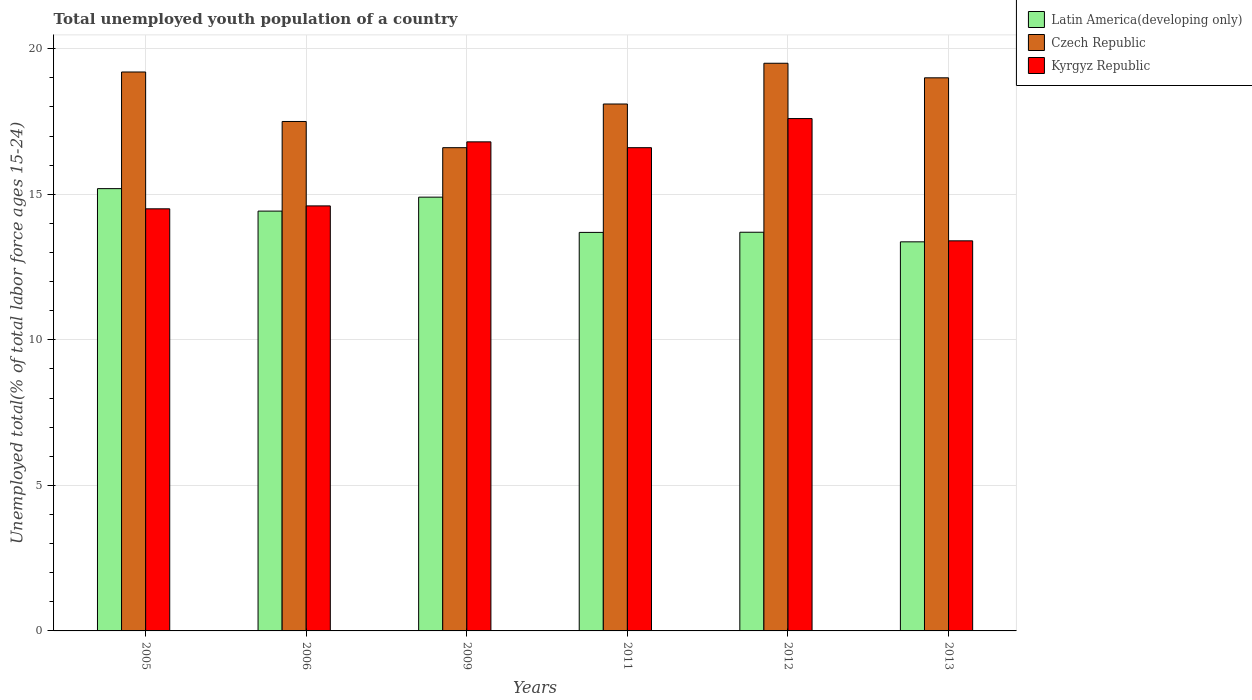How many different coloured bars are there?
Provide a succinct answer. 3. How many bars are there on the 6th tick from the left?
Provide a short and direct response. 3. How many bars are there on the 2nd tick from the right?
Your response must be concise. 3. What is the label of the 3rd group of bars from the left?
Keep it short and to the point. 2009. In how many cases, is the number of bars for a given year not equal to the number of legend labels?
Make the answer very short. 0. What is the percentage of total unemployed youth population of a country in Latin America(developing only) in 2009?
Provide a short and direct response. 14.9. Across all years, what is the maximum percentage of total unemployed youth population of a country in Kyrgyz Republic?
Give a very brief answer. 17.6. Across all years, what is the minimum percentage of total unemployed youth population of a country in Czech Republic?
Give a very brief answer. 16.6. In which year was the percentage of total unemployed youth population of a country in Kyrgyz Republic maximum?
Make the answer very short. 2012. In which year was the percentage of total unemployed youth population of a country in Latin America(developing only) minimum?
Offer a terse response. 2013. What is the total percentage of total unemployed youth population of a country in Kyrgyz Republic in the graph?
Your response must be concise. 93.5. What is the difference between the percentage of total unemployed youth population of a country in Latin America(developing only) in 2006 and that in 2013?
Give a very brief answer. 1.06. What is the difference between the percentage of total unemployed youth population of a country in Kyrgyz Republic in 2009 and the percentage of total unemployed youth population of a country in Czech Republic in 2012?
Keep it short and to the point. -2.7. What is the average percentage of total unemployed youth population of a country in Czech Republic per year?
Keep it short and to the point. 18.32. In the year 2012, what is the difference between the percentage of total unemployed youth population of a country in Latin America(developing only) and percentage of total unemployed youth population of a country in Czech Republic?
Give a very brief answer. -5.8. What is the ratio of the percentage of total unemployed youth population of a country in Latin America(developing only) in 2005 to that in 2006?
Offer a terse response. 1.05. Is the difference between the percentage of total unemployed youth population of a country in Latin America(developing only) in 2005 and 2009 greater than the difference between the percentage of total unemployed youth population of a country in Czech Republic in 2005 and 2009?
Your response must be concise. No. What is the difference between the highest and the second highest percentage of total unemployed youth population of a country in Czech Republic?
Keep it short and to the point. 0.3. What is the difference between the highest and the lowest percentage of total unemployed youth population of a country in Kyrgyz Republic?
Offer a very short reply. 4.2. What does the 3rd bar from the left in 2006 represents?
Give a very brief answer. Kyrgyz Republic. What does the 1st bar from the right in 2006 represents?
Offer a terse response. Kyrgyz Republic. How many bars are there?
Give a very brief answer. 18. Are all the bars in the graph horizontal?
Your answer should be very brief. No. Are the values on the major ticks of Y-axis written in scientific E-notation?
Provide a succinct answer. No. What is the title of the graph?
Your answer should be very brief. Total unemployed youth population of a country. What is the label or title of the X-axis?
Provide a succinct answer. Years. What is the label or title of the Y-axis?
Make the answer very short. Unemployed total(% of total labor force ages 15-24). What is the Unemployed total(% of total labor force ages 15-24) in Latin America(developing only) in 2005?
Your answer should be compact. 15.19. What is the Unemployed total(% of total labor force ages 15-24) in Czech Republic in 2005?
Offer a very short reply. 19.2. What is the Unemployed total(% of total labor force ages 15-24) of Kyrgyz Republic in 2005?
Make the answer very short. 14.5. What is the Unemployed total(% of total labor force ages 15-24) in Latin America(developing only) in 2006?
Your answer should be compact. 14.42. What is the Unemployed total(% of total labor force ages 15-24) in Kyrgyz Republic in 2006?
Offer a terse response. 14.6. What is the Unemployed total(% of total labor force ages 15-24) of Latin America(developing only) in 2009?
Offer a terse response. 14.9. What is the Unemployed total(% of total labor force ages 15-24) in Czech Republic in 2009?
Give a very brief answer. 16.6. What is the Unemployed total(% of total labor force ages 15-24) in Kyrgyz Republic in 2009?
Keep it short and to the point. 16.8. What is the Unemployed total(% of total labor force ages 15-24) in Latin America(developing only) in 2011?
Give a very brief answer. 13.69. What is the Unemployed total(% of total labor force ages 15-24) of Czech Republic in 2011?
Your answer should be compact. 18.1. What is the Unemployed total(% of total labor force ages 15-24) in Kyrgyz Republic in 2011?
Your response must be concise. 16.6. What is the Unemployed total(% of total labor force ages 15-24) of Latin America(developing only) in 2012?
Make the answer very short. 13.7. What is the Unemployed total(% of total labor force ages 15-24) in Czech Republic in 2012?
Your answer should be very brief. 19.5. What is the Unemployed total(% of total labor force ages 15-24) of Kyrgyz Republic in 2012?
Your response must be concise. 17.6. What is the Unemployed total(% of total labor force ages 15-24) in Latin America(developing only) in 2013?
Make the answer very short. 13.37. What is the Unemployed total(% of total labor force ages 15-24) in Czech Republic in 2013?
Give a very brief answer. 19. What is the Unemployed total(% of total labor force ages 15-24) in Kyrgyz Republic in 2013?
Keep it short and to the point. 13.4. Across all years, what is the maximum Unemployed total(% of total labor force ages 15-24) of Latin America(developing only)?
Make the answer very short. 15.19. Across all years, what is the maximum Unemployed total(% of total labor force ages 15-24) in Czech Republic?
Ensure brevity in your answer.  19.5. Across all years, what is the maximum Unemployed total(% of total labor force ages 15-24) in Kyrgyz Republic?
Keep it short and to the point. 17.6. Across all years, what is the minimum Unemployed total(% of total labor force ages 15-24) of Latin America(developing only)?
Your response must be concise. 13.37. Across all years, what is the minimum Unemployed total(% of total labor force ages 15-24) of Czech Republic?
Your answer should be compact. 16.6. Across all years, what is the minimum Unemployed total(% of total labor force ages 15-24) of Kyrgyz Republic?
Provide a short and direct response. 13.4. What is the total Unemployed total(% of total labor force ages 15-24) in Latin America(developing only) in the graph?
Make the answer very short. 85.27. What is the total Unemployed total(% of total labor force ages 15-24) in Czech Republic in the graph?
Your answer should be compact. 109.9. What is the total Unemployed total(% of total labor force ages 15-24) of Kyrgyz Republic in the graph?
Provide a short and direct response. 93.5. What is the difference between the Unemployed total(% of total labor force ages 15-24) of Latin America(developing only) in 2005 and that in 2006?
Your answer should be very brief. 0.77. What is the difference between the Unemployed total(% of total labor force ages 15-24) of Czech Republic in 2005 and that in 2006?
Give a very brief answer. 1.7. What is the difference between the Unemployed total(% of total labor force ages 15-24) of Latin America(developing only) in 2005 and that in 2009?
Provide a short and direct response. 0.29. What is the difference between the Unemployed total(% of total labor force ages 15-24) of Latin America(developing only) in 2005 and that in 2011?
Ensure brevity in your answer.  1.5. What is the difference between the Unemployed total(% of total labor force ages 15-24) of Latin America(developing only) in 2005 and that in 2012?
Make the answer very short. 1.5. What is the difference between the Unemployed total(% of total labor force ages 15-24) of Czech Republic in 2005 and that in 2012?
Ensure brevity in your answer.  -0.3. What is the difference between the Unemployed total(% of total labor force ages 15-24) of Kyrgyz Republic in 2005 and that in 2012?
Give a very brief answer. -3.1. What is the difference between the Unemployed total(% of total labor force ages 15-24) in Latin America(developing only) in 2005 and that in 2013?
Give a very brief answer. 1.83. What is the difference between the Unemployed total(% of total labor force ages 15-24) in Czech Republic in 2005 and that in 2013?
Your response must be concise. 0.2. What is the difference between the Unemployed total(% of total labor force ages 15-24) in Latin America(developing only) in 2006 and that in 2009?
Ensure brevity in your answer.  -0.48. What is the difference between the Unemployed total(% of total labor force ages 15-24) in Czech Republic in 2006 and that in 2009?
Make the answer very short. 0.9. What is the difference between the Unemployed total(% of total labor force ages 15-24) of Kyrgyz Republic in 2006 and that in 2009?
Offer a very short reply. -2.2. What is the difference between the Unemployed total(% of total labor force ages 15-24) of Latin America(developing only) in 2006 and that in 2011?
Your answer should be very brief. 0.73. What is the difference between the Unemployed total(% of total labor force ages 15-24) in Kyrgyz Republic in 2006 and that in 2011?
Your answer should be very brief. -2. What is the difference between the Unemployed total(% of total labor force ages 15-24) of Latin America(developing only) in 2006 and that in 2012?
Give a very brief answer. 0.73. What is the difference between the Unemployed total(% of total labor force ages 15-24) in Czech Republic in 2006 and that in 2012?
Provide a short and direct response. -2. What is the difference between the Unemployed total(% of total labor force ages 15-24) of Latin America(developing only) in 2006 and that in 2013?
Your response must be concise. 1.06. What is the difference between the Unemployed total(% of total labor force ages 15-24) in Kyrgyz Republic in 2006 and that in 2013?
Provide a succinct answer. 1.2. What is the difference between the Unemployed total(% of total labor force ages 15-24) in Latin America(developing only) in 2009 and that in 2011?
Provide a short and direct response. 1.21. What is the difference between the Unemployed total(% of total labor force ages 15-24) in Latin America(developing only) in 2009 and that in 2012?
Offer a very short reply. 1.21. What is the difference between the Unemployed total(% of total labor force ages 15-24) of Czech Republic in 2009 and that in 2012?
Offer a very short reply. -2.9. What is the difference between the Unemployed total(% of total labor force ages 15-24) of Latin America(developing only) in 2009 and that in 2013?
Offer a terse response. 1.53. What is the difference between the Unemployed total(% of total labor force ages 15-24) of Latin America(developing only) in 2011 and that in 2012?
Your answer should be compact. -0.01. What is the difference between the Unemployed total(% of total labor force ages 15-24) in Czech Republic in 2011 and that in 2012?
Ensure brevity in your answer.  -1.4. What is the difference between the Unemployed total(% of total labor force ages 15-24) of Kyrgyz Republic in 2011 and that in 2012?
Provide a succinct answer. -1. What is the difference between the Unemployed total(% of total labor force ages 15-24) in Latin America(developing only) in 2011 and that in 2013?
Offer a very short reply. 0.32. What is the difference between the Unemployed total(% of total labor force ages 15-24) in Czech Republic in 2011 and that in 2013?
Your response must be concise. -0.9. What is the difference between the Unemployed total(% of total labor force ages 15-24) in Latin America(developing only) in 2012 and that in 2013?
Your answer should be very brief. 0.33. What is the difference between the Unemployed total(% of total labor force ages 15-24) in Latin America(developing only) in 2005 and the Unemployed total(% of total labor force ages 15-24) in Czech Republic in 2006?
Give a very brief answer. -2.31. What is the difference between the Unemployed total(% of total labor force ages 15-24) in Latin America(developing only) in 2005 and the Unemployed total(% of total labor force ages 15-24) in Kyrgyz Republic in 2006?
Provide a succinct answer. 0.59. What is the difference between the Unemployed total(% of total labor force ages 15-24) of Latin America(developing only) in 2005 and the Unemployed total(% of total labor force ages 15-24) of Czech Republic in 2009?
Provide a succinct answer. -1.41. What is the difference between the Unemployed total(% of total labor force ages 15-24) of Latin America(developing only) in 2005 and the Unemployed total(% of total labor force ages 15-24) of Kyrgyz Republic in 2009?
Keep it short and to the point. -1.61. What is the difference between the Unemployed total(% of total labor force ages 15-24) of Latin America(developing only) in 2005 and the Unemployed total(% of total labor force ages 15-24) of Czech Republic in 2011?
Offer a very short reply. -2.91. What is the difference between the Unemployed total(% of total labor force ages 15-24) in Latin America(developing only) in 2005 and the Unemployed total(% of total labor force ages 15-24) in Kyrgyz Republic in 2011?
Give a very brief answer. -1.41. What is the difference between the Unemployed total(% of total labor force ages 15-24) in Latin America(developing only) in 2005 and the Unemployed total(% of total labor force ages 15-24) in Czech Republic in 2012?
Ensure brevity in your answer.  -4.31. What is the difference between the Unemployed total(% of total labor force ages 15-24) of Latin America(developing only) in 2005 and the Unemployed total(% of total labor force ages 15-24) of Kyrgyz Republic in 2012?
Offer a very short reply. -2.41. What is the difference between the Unemployed total(% of total labor force ages 15-24) of Latin America(developing only) in 2005 and the Unemployed total(% of total labor force ages 15-24) of Czech Republic in 2013?
Ensure brevity in your answer.  -3.81. What is the difference between the Unemployed total(% of total labor force ages 15-24) of Latin America(developing only) in 2005 and the Unemployed total(% of total labor force ages 15-24) of Kyrgyz Republic in 2013?
Provide a short and direct response. 1.79. What is the difference between the Unemployed total(% of total labor force ages 15-24) in Latin America(developing only) in 2006 and the Unemployed total(% of total labor force ages 15-24) in Czech Republic in 2009?
Offer a very short reply. -2.18. What is the difference between the Unemployed total(% of total labor force ages 15-24) of Latin America(developing only) in 2006 and the Unemployed total(% of total labor force ages 15-24) of Kyrgyz Republic in 2009?
Provide a short and direct response. -2.38. What is the difference between the Unemployed total(% of total labor force ages 15-24) of Czech Republic in 2006 and the Unemployed total(% of total labor force ages 15-24) of Kyrgyz Republic in 2009?
Offer a very short reply. 0.7. What is the difference between the Unemployed total(% of total labor force ages 15-24) in Latin America(developing only) in 2006 and the Unemployed total(% of total labor force ages 15-24) in Czech Republic in 2011?
Your response must be concise. -3.68. What is the difference between the Unemployed total(% of total labor force ages 15-24) of Latin America(developing only) in 2006 and the Unemployed total(% of total labor force ages 15-24) of Kyrgyz Republic in 2011?
Give a very brief answer. -2.18. What is the difference between the Unemployed total(% of total labor force ages 15-24) in Latin America(developing only) in 2006 and the Unemployed total(% of total labor force ages 15-24) in Czech Republic in 2012?
Make the answer very short. -5.08. What is the difference between the Unemployed total(% of total labor force ages 15-24) in Latin America(developing only) in 2006 and the Unemployed total(% of total labor force ages 15-24) in Kyrgyz Republic in 2012?
Your response must be concise. -3.18. What is the difference between the Unemployed total(% of total labor force ages 15-24) in Latin America(developing only) in 2006 and the Unemployed total(% of total labor force ages 15-24) in Czech Republic in 2013?
Provide a succinct answer. -4.58. What is the difference between the Unemployed total(% of total labor force ages 15-24) of Latin America(developing only) in 2006 and the Unemployed total(% of total labor force ages 15-24) of Kyrgyz Republic in 2013?
Offer a very short reply. 1.02. What is the difference between the Unemployed total(% of total labor force ages 15-24) in Latin America(developing only) in 2009 and the Unemployed total(% of total labor force ages 15-24) in Czech Republic in 2011?
Your answer should be compact. -3.2. What is the difference between the Unemployed total(% of total labor force ages 15-24) of Latin America(developing only) in 2009 and the Unemployed total(% of total labor force ages 15-24) of Kyrgyz Republic in 2011?
Offer a terse response. -1.7. What is the difference between the Unemployed total(% of total labor force ages 15-24) in Czech Republic in 2009 and the Unemployed total(% of total labor force ages 15-24) in Kyrgyz Republic in 2011?
Offer a very short reply. 0. What is the difference between the Unemployed total(% of total labor force ages 15-24) in Latin America(developing only) in 2009 and the Unemployed total(% of total labor force ages 15-24) in Czech Republic in 2012?
Give a very brief answer. -4.6. What is the difference between the Unemployed total(% of total labor force ages 15-24) of Latin America(developing only) in 2009 and the Unemployed total(% of total labor force ages 15-24) of Kyrgyz Republic in 2012?
Your answer should be compact. -2.7. What is the difference between the Unemployed total(% of total labor force ages 15-24) of Czech Republic in 2009 and the Unemployed total(% of total labor force ages 15-24) of Kyrgyz Republic in 2012?
Make the answer very short. -1. What is the difference between the Unemployed total(% of total labor force ages 15-24) of Latin America(developing only) in 2009 and the Unemployed total(% of total labor force ages 15-24) of Czech Republic in 2013?
Your response must be concise. -4.1. What is the difference between the Unemployed total(% of total labor force ages 15-24) of Latin America(developing only) in 2009 and the Unemployed total(% of total labor force ages 15-24) of Kyrgyz Republic in 2013?
Your answer should be very brief. 1.5. What is the difference between the Unemployed total(% of total labor force ages 15-24) in Latin America(developing only) in 2011 and the Unemployed total(% of total labor force ages 15-24) in Czech Republic in 2012?
Your response must be concise. -5.81. What is the difference between the Unemployed total(% of total labor force ages 15-24) in Latin America(developing only) in 2011 and the Unemployed total(% of total labor force ages 15-24) in Kyrgyz Republic in 2012?
Provide a short and direct response. -3.91. What is the difference between the Unemployed total(% of total labor force ages 15-24) of Czech Republic in 2011 and the Unemployed total(% of total labor force ages 15-24) of Kyrgyz Republic in 2012?
Your response must be concise. 0.5. What is the difference between the Unemployed total(% of total labor force ages 15-24) of Latin America(developing only) in 2011 and the Unemployed total(% of total labor force ages 15-24) of Czech Republic in 2013?
Ensure brevity in your answer.  -5.31. What is the difference between the Unemployed total(% of total labor force ages 15-24) of Latin America(developing only) in 2011 and the Unemployed total(% of total labor force ages 15-24) of Kyrgyz Republic in 2013?
Ensure brevity in your answer.  0.29. What is the difference between the Unemployed total(% of total labor force ages 15-24) in Czech Republic in 2011 and the Unemployed total(% of total labor force ages 15-24) in Kyrgyz Republic in 2013?
Keep it short and to the point. 4.7. What is the difference between the Unemployed total(% of total labor force ages 15-24) in Latin America(developing only) in 2012 and the Unemployed total(% of total labor force ages 15-24) in Czech Republic in 2013?
Provide a short and direct response. -5.3. What is the difference between the Unemployed total(% of total labor force ages 15-24) in Latin America(developing only) in 2012 and the Unemployed total(% of total labor force ages 15-24) in Kyrgyz Republic in 2013?
Make the answer very short. 0.3. What is the difference between the Unemployed total(% of total labor force ages 15-24) in Czech Republic in 2012 and the Unemployed total(% of total labor force ages 15-24) in Kyrgyz Republic in 2013?
Ensure brevity in your answer.  6.1. What is the average Unemployed total(% of total labor force ages 15-24) in Latin America(developing only) per year?
Ensure brevity in your answer.  14.21. What is the average Unemployed total(% of total labor force ages 15-24) of Czech Republic per year?
Ensure brevity in your answer.  18.32. What is the average Unemployed total(% of total labor force ages 15-24) of Kyrgyz Republic per year?
Keep it short and to the point. 15.58. In the year 2005, what is the difference between the Unemployed total(% of total labor force ages 15-24) of Latin America(developing only) and Unemployed total(% of total labor force ages 15-24) of Czech Republic?
Offer a very short reply. -4.01. In the year 2005, what is the difference between the Unemployed total(% of total labor force ages 15-24) in Latin America(developing only) and Unemployed total(% of total labor force ages 15-24) in Kyrgyz Republic?
Your answer should be compact. 0.69. In the year 2005, what is the difference between the Unemployed total(% of total labor force ages 15-24) in Czech Republic and Unemployed total(% of total labor force ages 15-24) in Kyrgyz Republic?
Make the answer very short. 4.7. In the year 2006, what is the difference between the Unemployed total(% of total labor force ages 15-24) in Latin America(developing only) and Unemployed total(% of total labor force ages 15-24) in Czech Republic?
Offer a very short reply. -3.08. In the year 2006, what is the difference between the Unemployed total(% of total labor force ages 15-24) of Latin America(developing only) and Unemployed total(% of total labor force ages 15-24) of Kyrgyz Republic?
Give a very brief answer. -0.18. In the year 2009, what is the difference between the Unemployed total(% of total labor force ages 15-24) in Latin America(developing only) and Unemployed total(% of total labor force ages 15-24) in Czech Republic?
Make the answer very short. -1.7. In the year 2009, what is the difference between the Unemployed total(% of total labor force ages 15-24) of Latin America(developing only) and Unemployed total(% of total labor force ages 15-24) of Kyrgyz Republic?
Provide a short and direct response. -1.9. In the year 2011, what is the difference between the Unemployed total(% of total labor force ages 15-24) in Latin America(developing only) and Unemployed total(% of total labor force ages 15-24) in Czech Republic?
Your answer should be very brief. -4.41. In the year 2011, what is the difference between the Unemployed total(% of total labor force ages 15-24) of Latin America(developing only) and Unemployed total(% of total labor force ages 15-24) of Kyrgyz Republic?
Your response must be concise. -2.91. In the year 2012, what is the difference between the Unemployed total(% of total labor force ages 15-24) of Latin America(developing only) and Unemployed total(% of total labor force ages 15-24) of Czech Republic?
Your response must be concise. -5.8. In the year 2012, what is the difference between the Unemployed total(% of total labor force ages 15-24) of Latin America(developing only) and Unemployed total(% of total labor force ages 15-24) of Kyrgyz Republic?
Provide a succinct answer. -3.9. In the year 2012, what is the difference between the Unemployed total(% of total labor force ages 15-24) of Czech Republic and Unemployed total(% of total labor force ages 15-24) of Kyrgyz Republic?
Your answer should be very brief. 1.9. In the year 2013, what is the difference between the Unemployed total(% of total labor force ages 15-24) of Latin America(developing only) and Unemployed total(% of total labor force ages 15-24) of Czech Republic?
Provide a succinct answer. -5.63. In the year 2013, what is the difference between the Unemployed total(% of total labor force ages 15-24) in Latin America(developing only) and Unemployed total(% of total labor force ages 15-24) in Kyrgyz Republic?
Offer a very short reply. -0.03. In the year 2013, what is the difference between the Unemployed total(% of total labor force ages 15-24) in Czech Republic and Unemployed total(% of total labor force ages 15-24) in Kyrgyz Republic?
Give a very brief answer. 5.6. What is the ratio of the Unemployed total(% of total labor force ages 15-24) of Latin America(developing only) in 2005 to that in 2006?
Offer a terse response. 1.05. What is the ratio of the Unemployed total(% of total labor force ages 15-24) of Czech Republic in 2005 to that in 2006?
Ensure brevity in your answer.  1.1. What is the ratio of the Unemployed total(% of total labor force ages 15-24) of Kyrgyz Republic in 2005 to that in 2006?
Keep it short and to the point. 0.99. What is the ratio of the Unemployed total(% of total labor force ages 15-24) in Latin America(developing only) in 2005 to that in 2009?
Make the answer very short. 1.02. What is the ratio of the Unemployed total(% of total labor force ages 15-24) of Czech Republic in 2005 to that in 2009?
Provide a short and direct response. 1.16. What is the ratio of the Unemployed total(% of total labor force ages 15-24) of Kyrgyz Republic in 2005 to that in 2009?
Provide a short and direct response. 0.86. What is the ratio of the Unemployed total(% of total labor force ages 15-24) in Latin America(developing only) in 2005 to that in 2011?
Make the answer very short. 1.11. What is the ratio of the Unemployed total(% of total labor force ages 15-24) of Czech Republic in 2005 to that in 2011?
Ensure brevity in your answer.  1.06. What is the ratio of the Unemployed total(% of total labor force ages 15-24) in Kyrgyz Republic in 2005 to that in 2011?
Provide a succinct answer. 0.87. What is the ratio of the Unemployed total(% of total labor force ages 15-24) in Latin America(developing only) in 2005 to that in 2012?
Ensure brevity in your answer.  1.11. What is the ratio of the Unemployed total(% of total labor force ages 15-24) in Czech Republic in 2005 to that in 2012?
Your answer should be compact. 0.98. What is the ratio of the Unemployed total(% of total labor force ages 15-24) of Kyrgyz Republic in 2005 to that in 2012?
Your response must be concise. 0.82. What is the ratio of the Unemployed total(% of total labor force ages 15-24) in Latin America(developing only) in 2005 to that in 2013?
Provide a short and direct response. 1.14. What is the ratio of the Unemployed total(% of total labor force ages 15-24) in Czech Republic in 2005 to that in 2013?
Offer a terse response. 1.01. What is the ratio of the Unemployed total(% of total labor force ages 15-24) of Kyrgyz Republic in 2005 to that in 2013?
Offer a very short reply. 1.08. What is the ratio of the Unemployed total(% of total labor force ages 15-24) of Latin America(developing only) in 2006 to that in 2009?
Keep it short and to the point. 0.97. What is the ratio of the Unemployed total(% of total labor force ages 15-24) in Czech Republic in 2006 to that in 2009?
Keep it short and to the point. 1.05. What is the ratio of the Unemployed total(% of total labor force ages 15-24) in Kyrgyz Republic in 2006 to that in 2009?
Give a very brief answer. 0.87. What is the ratio of the Unemployed total(% of total labor force ages 15-24) of Latin America(developing only) in 2006 to that in 2011?
Offer a terse response. 1.05. What is the ratio of the Unemployed total(% of total labor force ages 15-24) of Czech Republic in 2006 to that in 2011?
Give a very brief answer. 0.97. What is the ratio of the Unemployed total(% of total labor force ages 15-24) of Kyrgyz Republic in 2006 to that in 2011?
Offer a very short reply. 0.88. What is the ratio of the Unemployed total(% of total labor force ages 15-24) in Latin America(developing only) in 2006 to that in 2012?
Your answer should be very brief. 1.05. What is the ratio of the Unemployed total(% of total labor force ages 15-24) of Czech Republic in 2006 to that in 2012?
Your answer should be compact. 0.9. What is the ratio of the Unemployed total(% of total labor force ages 15-24) in Kyrgyz Republic in 2006 to that in 2012?
Offer a terse response. 0.83. What is the ratio of the Unemployed total(% of total labor force ages 15-24) in Latin America(developing only) in 2006 to that in 2013?
Offer a terse response. 1.08. What is the ratio of the Unemployed total(% of total labor force ages 15-24) of Czech Republic in 2006 to that in 2013?
Provide a succinct answer. 0.92. What is the ratio of the Unemployed total(% of total labor force ages 15-24) in Kyrgyz Republic in 2006 to that in 2013?
Give a very brief answer. 1.09. What is the ratio of the Unemployed total(% of total labor force ages 15-24) of Latin America(developing only) in 2009 to that in 2011?
Give a very brief answer. 1.09. What is the ratio of the Unemployed total(% of total labor force ages 15-24) in Czech Republic in 2009 to that in 2011?
Your answer should be very brief. 0.92. What is the ratio of the Unemployed total(% of total labor force ages 15-24) in Latin America(developing only) in 2009 to that in 2012?
Provide a succinct answer. 1.09. What is the ratio of the Unemployed total(% of total labor force ages 15-24) in Czech Republic in 2009 to that in 2012?
Offer a terse response. 0.85. What is the ratio of the Unemployed total(% of total labor force ages 15-24) in Kyrgyz Republic in 2009 to that in 2012?
Keep it short and to the point. 0.95. What is the ratio of the Unemployed total(% of total labor force ages 15-24) in Latin America(developing only) in 2009 to that in 2013?
Ensure brevity in your answer.  1.11. What is the ratio of the Unemployed total(% of total labor force ages 15-24) in Czech Republic in 2009 to that in 2013?
Your answer should be compact. 0.87. What is the ratio of the Unemployed total(% of total labor force ages 15-24) in Kyrgyz Republic in 2009 to that in 2013?
Offer a very short reply. 1.25. What is the ratio of the Unemployed total(% of total labor force ages 15-24) in Czech Republic in 2011 to that in 2012?
Offer a terse response. 0.93. What is the ratio of the Unemployed total(% of total labor force ages 15-24) of Kyrgyz Republic in 2011 to that in 2012?
Your answer should be compact. 0.94. What is the ratio of the Unemployed total(% of total labor force ages 15-24) in Latin America(developing only) in 2011 to that in 2013?
Your answer should be very brief. 1.02. What is the ratio of the Unemployed total(% of total labor force ages 15-24) of Czech Republic in 2011 to that in 2013?
Provide a short and direct response. 0.95. What is the ratio of the Unemployed total(% of total labor force ages 15-24) in Kyrgyz Republic in 2011 to that in 2013?
Provide a short and direct response. 1.24. What is the ratio of the Unemployed total(% of total labor force ages 15-24) in Latin America(developing only) in 2012 to that in 2013?
Your answer should be very brief. 1.02. What is the ratio of the Unemployed total(% of total labor force ages 15-24) of Czech Republic in 2012 to that in 2013?
Offer a terse response. 1.03. What is the ratio of the Unemployed total(% of total labor force ages 15-24) of Kyrgyz Republic in 2012 to that in 2013?
Give a very brief answer. 1.31. What is the difference between the highest and the second highest Unemployed total(% of total labor force ages 15-24) of Latin America(developing only)?
Your answer should be compact. 0.29. What is the difference between the highest and the second highest Unemployed total(% of total labor force ages 15-24) of Czech Republic?
Make the answer very short. 0.3. What is the difference between the highest and the second highest Unemployed total(% of total labor force ages 15-24) of Kyrgyz Republic?
Ensure brevity in your answer.  0.8. What is the difference between the highest and the lowest Unemployed total(% of total labor force ages 15-24) of Latin America(developing only)?
Your response must be concise. 1.83. What is the difference between the highest and the lowest Unemployed total(% of total labor force ages 15-24) in Kyrgyz Republic?
Offer a very short reply. 4.2. 